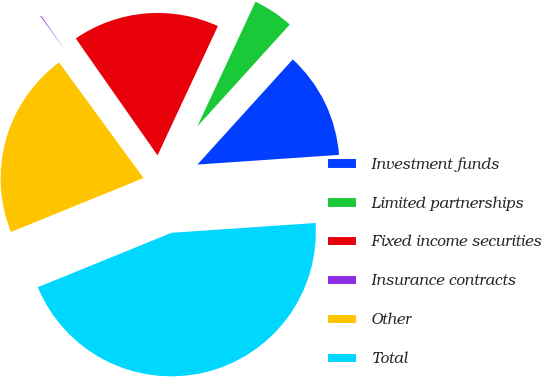<chart> <loc_0><loc_0><loc_500><loc_500><pie_chart><fcel>Investment funds<fcel>Limited partnerships<fcel>Fixed income securities<fcel>Insurance contracts<fcel>Other<fcel>Total<nl><fcel>12.19%<fcel>4.78%<fcel>16.66%<fcel>0.33%<fcel>21.11%<fcel>44.93%<nl></chart> 